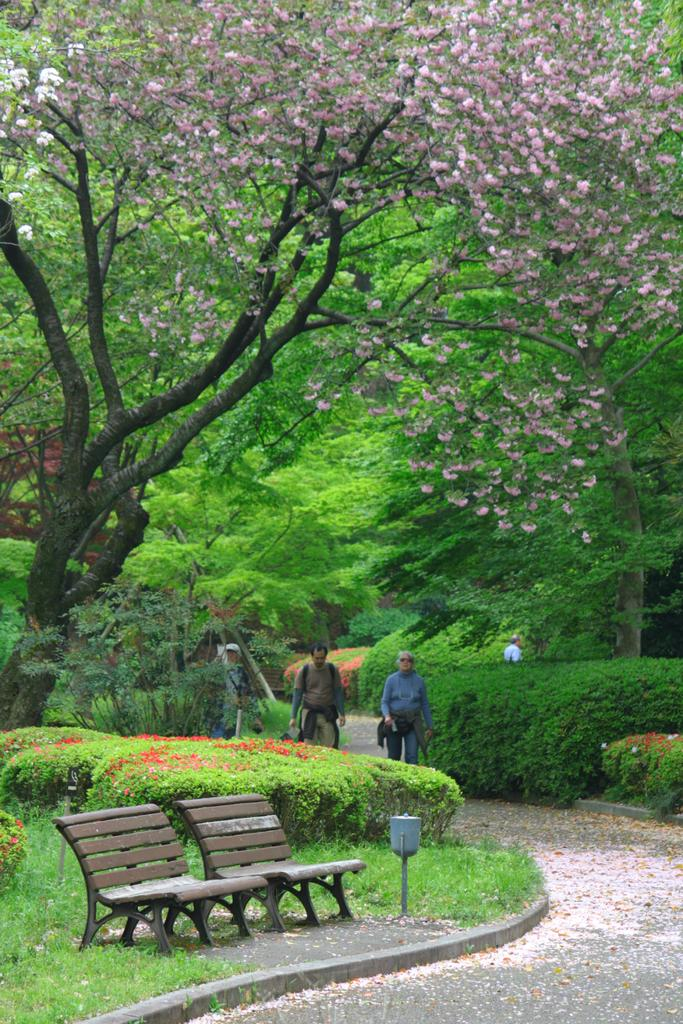How many benches are in the image? There are 2 benches in the image. What can be seen in the image besides the benches? There are many plants and trees in the image. How many people are in the image? There are 3 persons in the image. What is the purpose of the path visible in the image? The path is likely for walking or navigating through the area. What type of rod is being used by the beast in the image? There is no beast or rod present in the image. 